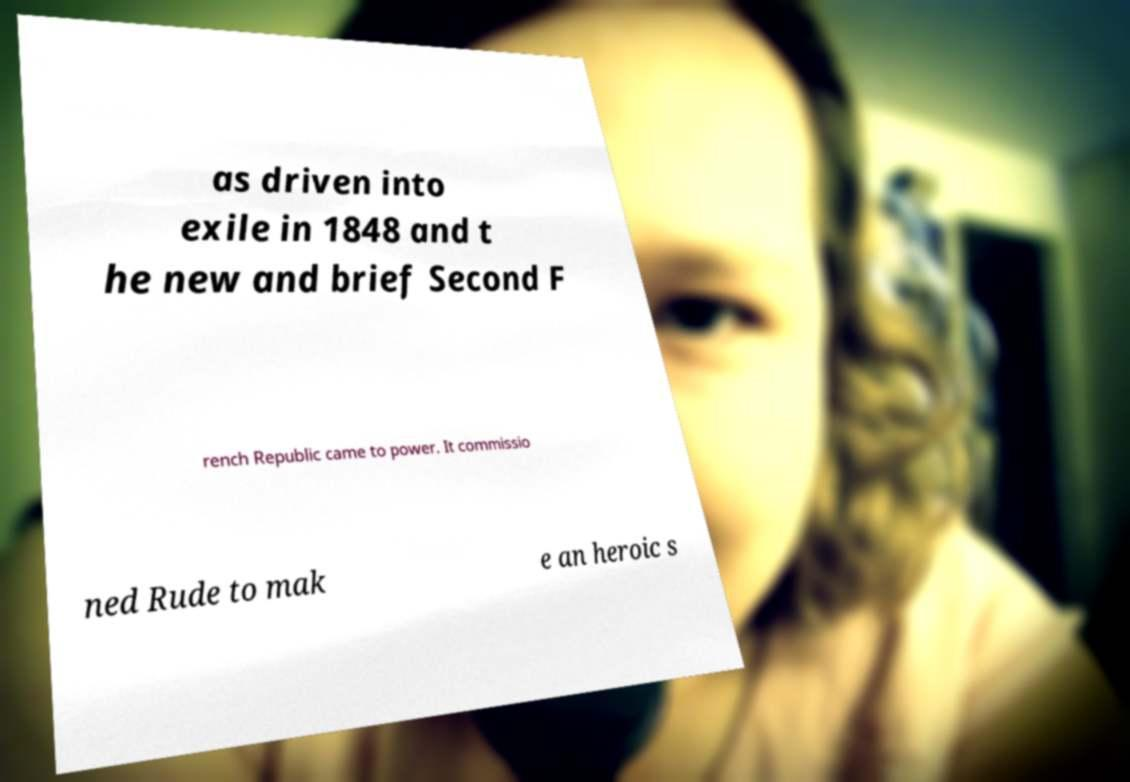Could you extract and type out the text from this image? as driven into exile in 1848 and t he new and brief Second F rench Republic came to power. It commissio ned Rude to mak e an heroic s 